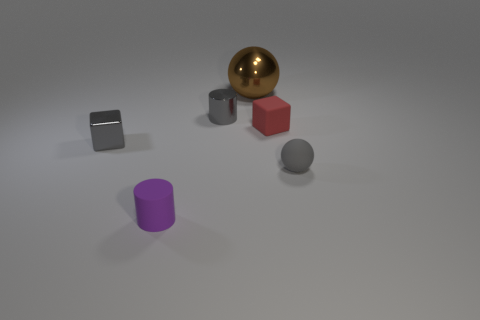There is a object that is behind the gray shiny object behind the tiny gray block; what shape is it?
Your answer should be compact. Sphere. What number of small rubber blocks are to the left of the matte cylinder?
Your response must be concise. 0. What color is the tiny object that is made of the same material as the gray cylinder?
Ensure brevity in your answer.  Gray. Is the size of the gray rubber sphere the same as the ball behind the gray sphere?
Offer a terse response. No. There is a ball in front of the small gray object to the left of the tiny cylinder that is behind the gray sphere; what is its size?
Offer a terse response. Small. How many matte things are either things or red things?
Provide a short and direct response. 3. What is the color of the small cylinder behind the small purple cylinder?
Offer a terse response. Gray. What shape is the red matte thing that is the same size as the gray shiny block?
Offer a very short reply. Cube. Does the metallic cube have the same color as the ball right of the brown thing?
Make the answer very short. Yes. How many things are shiny objects that are behind the small red block or tiny things left of the red matte thing?
Ensure brevity in your answer.  4. 